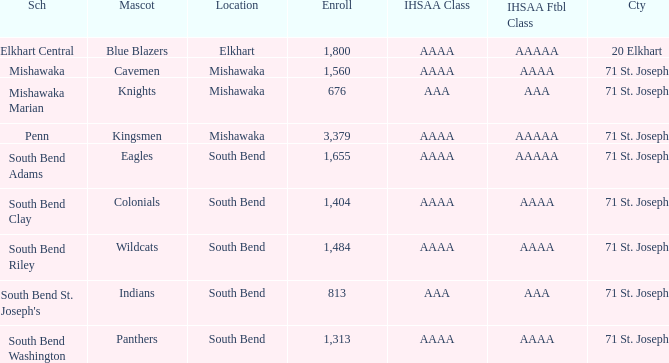What school has south bend as the location, with indians as the mascot? South Bend St. Joseph's. 